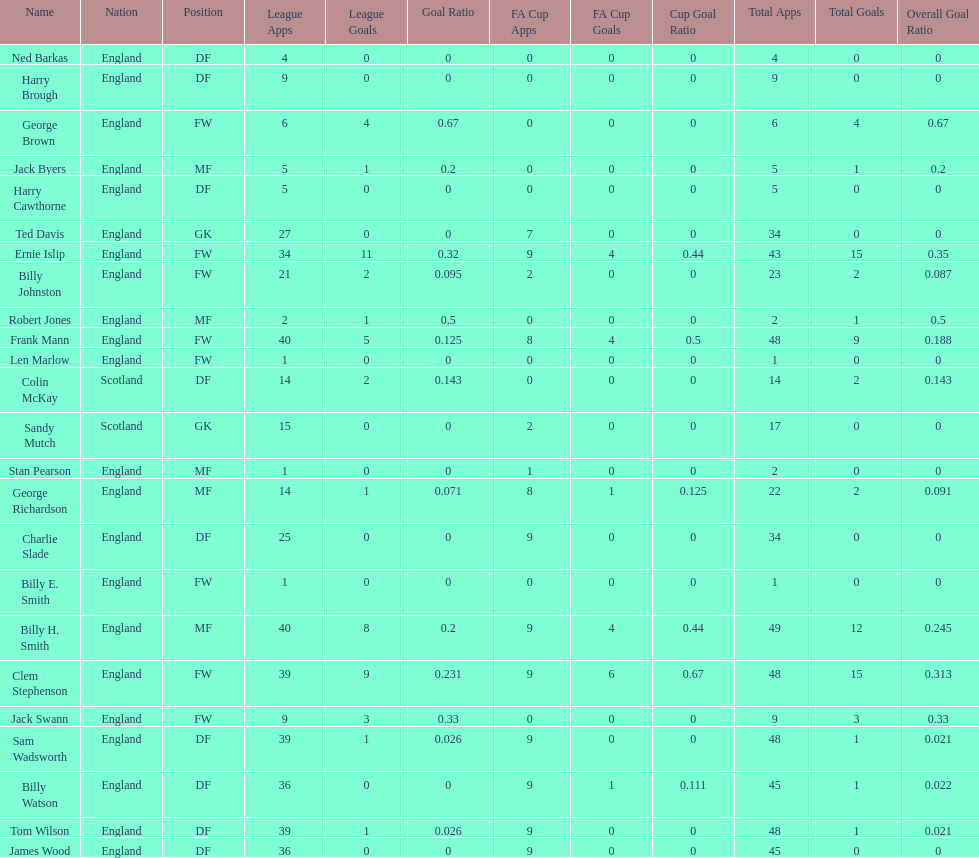What is the first name listed? Ned Barkas. 